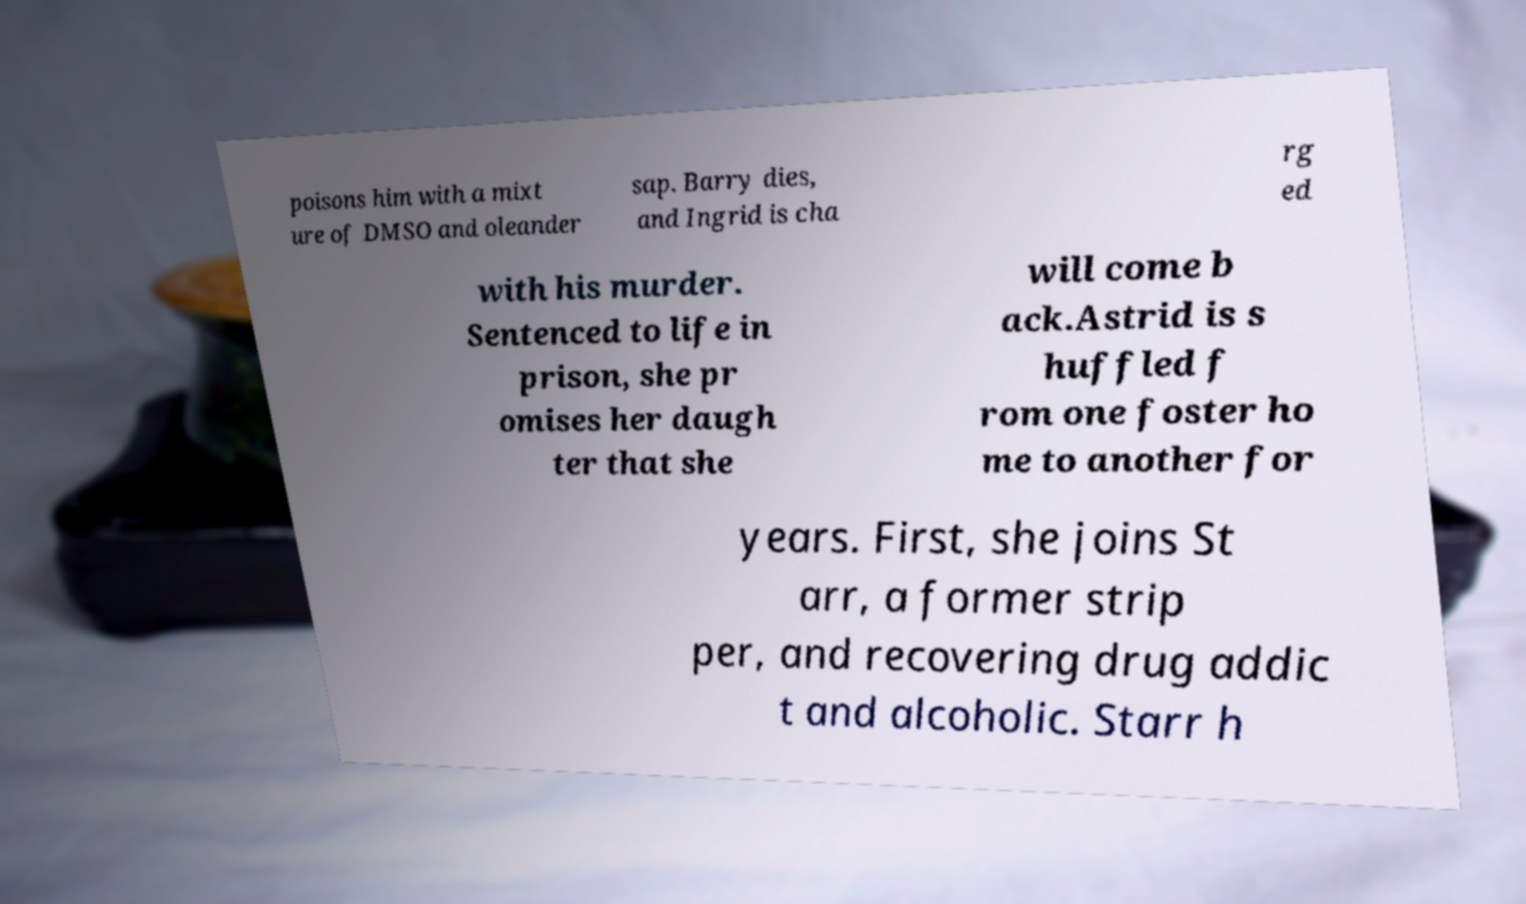Could you assist in decoding the text presented in this image and type it out clearly? poisons him with a mixt ure of DMSO and oleander sap. Barry dies, and Ingrid is cha rg ed with his murder. Sentenced to life in prison, she pr omises her daugh ter that she will come b ack.Astrid is s huffled f rom one foster ho me to another for years. First, she joins St arr, a former strip per, and recovering drug addic t and alcoholic. Starr h 